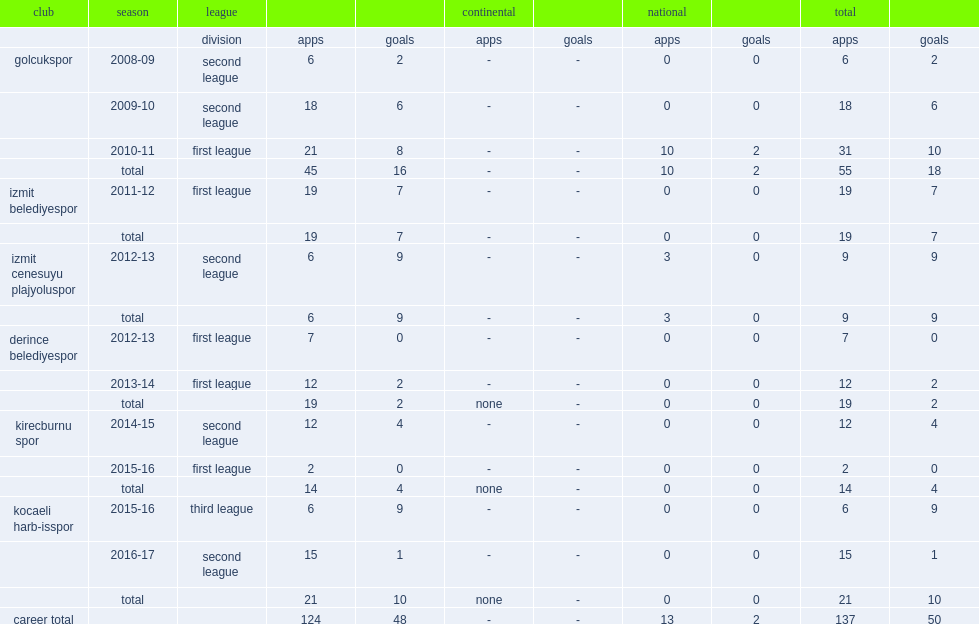Which club did buse gungor play for in 2014-15? Kirecburnu spor. 